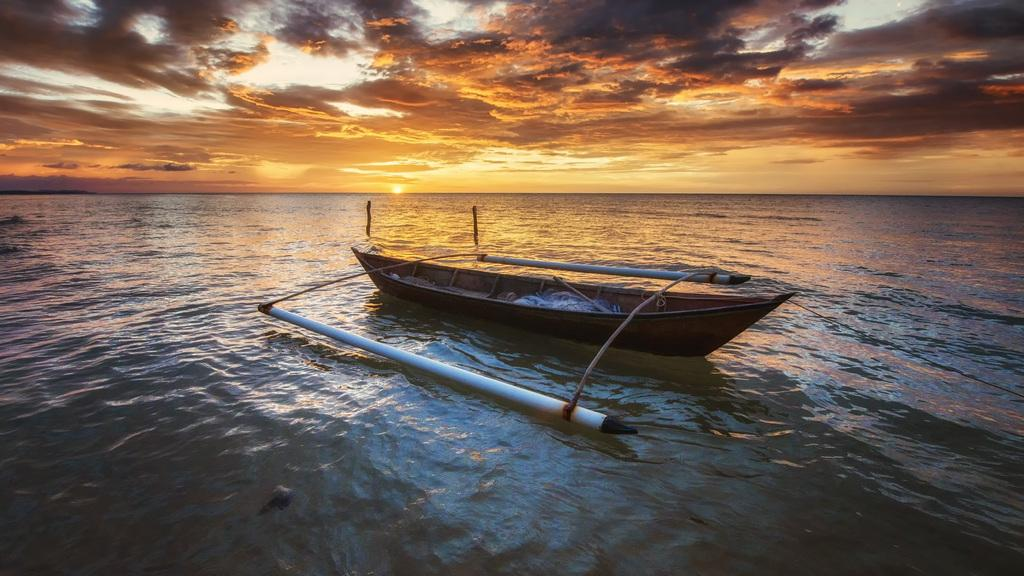What is the main subject of the image? The main subject of the image is a boat. Where is the boat located in the image? The boat is on the water. What can be seen in the background of the image? There is a sky visible in the background of the image. What is present in the sky in the image? Clouds are present in the sky. What is the chance of the boat catching the attention of the yarn in the image? There is no yarn present in the image, so it is not possible to determine the chance of the boat catching its attention. 